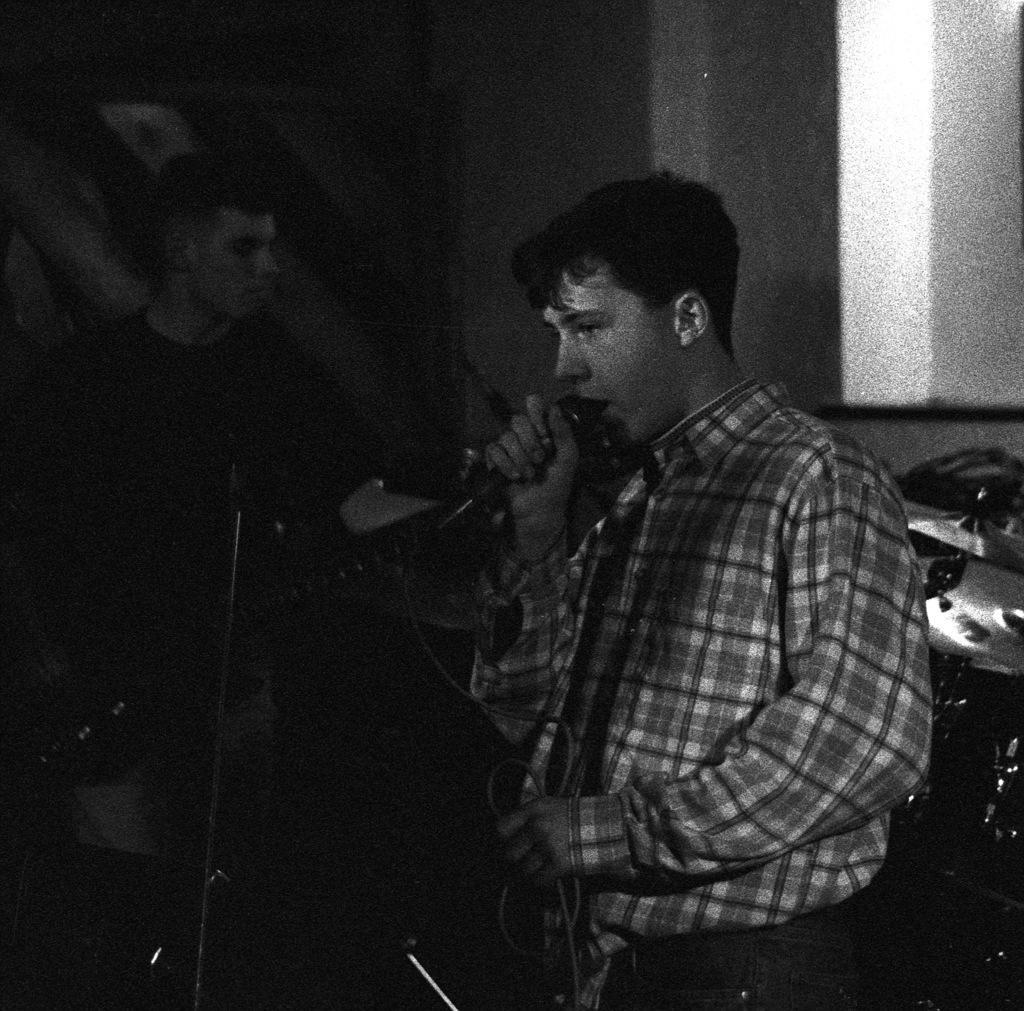Could you give a brief overview of what you see in this image? The two persons are playing a musical instruments. On the right side we have a check shirt person. He is holding a mic and he is singing a song. On the left side we have a another person. He is playing a musical instruments. We can see in background musical instruments and curtain. 